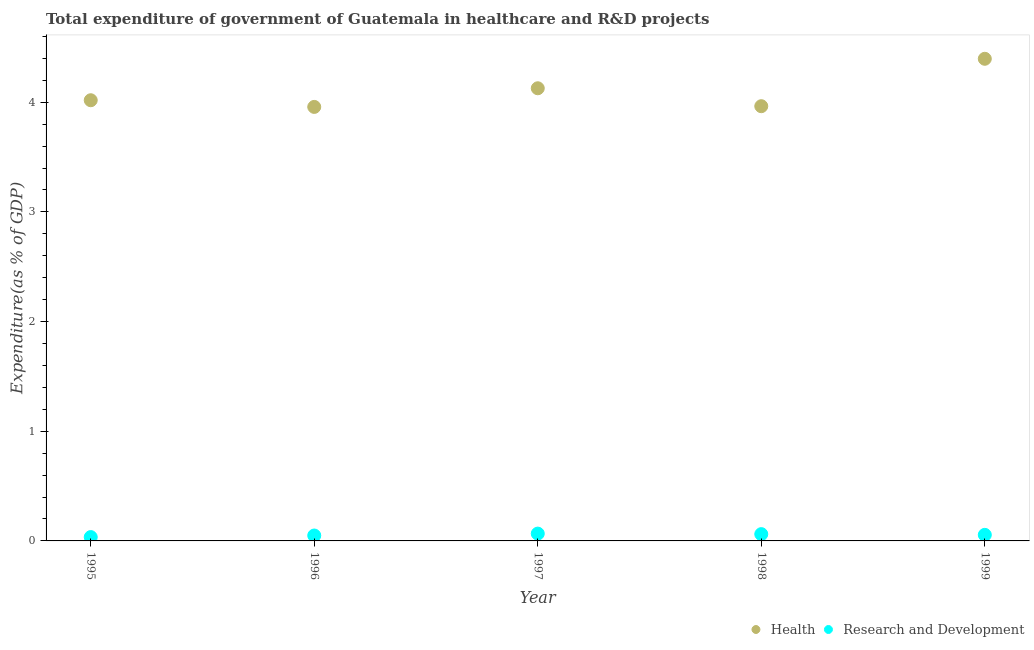Is the number of dotlines equal to the number of legend labels?
Your answer should be compact. Yes. What is the expenditure in r&d in 1998?
Provide a succinct answer. 0.06. Across all years, what is the maximum expenditure in r&d?
Make the answer very short. 0.07. Across all years, what is the minimum expenditure in r&d?
Offer a terse response. 0.04. What is the total expenditure in r&d in the graph?
Make the answer very short. 0.27. What is the difference between the expenditure in r&d in 1995 and that in 1996?
Your answer should be compact. -0.01. What is the difference between the expenditure in r&d in 1997 and the expenditure in healthcare in 1999?
Make the answer very short. -4.33. What is the average expenditure in r&d per year?
Make the answer very short. 0.05. In the year 1995, what is the difference between the expenditure in healthcare and expenditure in r&d?
Provide a short and direct response. 3.98. In how many years, is the expenditure in r&d greater than 2.8 %?
Keep it short and to the point. 0. What is the ratio of the expenditure in r&d in 1996 to that in 1997?
Offer a very short reply. 0.74. Is the expenditure in healthcare in 1998 less than that in 1999?
Your answer should be very brief. Yes. What is the difference between the highest and the second highest expenditure in healthcare?
Your answer should be very brief. 0.27. What is the difference between the highest and the lowest expenditure in healthcare?
Your answer should be very brief. 0.44. Is the sum of the expenditure in healthcare in 1996 and 1999 greater than the maximum expenditure in r&d across all years?
Make the answer very short. Yes. Does the expenditure in r&d monotonically increase over the years?
Offer a very short reply. No. How many years are there in the graph?
Your answer should be very brief. 5. What is the difference between two consecutive major ticks on the Y-axis?
Your answer should be very brief. 1. Are the values on the major ticks of Y-axis written in scientific E-notation?
Offer a terse response. No. Does the graph contain grids?
Keep it short and to the point. No. Where does the legend appear in the graph?
Offer a terse response. Bottom right. How are the legend labels stacked?
Offer a terse response. Horizontal. What is the title of the graph?
Provide a succinct answer. Total expenditure of government of Guatemala in healthcare and R&D projects. Does "Goods and services" appear as one of the legend labels in the graph?
Your response must be concise. No. What is the label or title of the X-axis?
Offer a terse response. Year. What is the label or title of the Y-axis?
Your answer should be compact. Expenditure(as % of GDP). What is the Expenditure(as % of GDP) in Health in 1995?
Ensure brevity in your answer.  4.02. What is the Expenditure(as % of GDP) in Research and Development in 1995?
Keep it short and to the point. 0.04. What is the Expenditure(as % of GDP) in Health in 1996?
Provide a succinct answer. 3.96. What is the Expenditure(as % of GDP) in Research and Development in 1996?
Give a very brief answer. 0.05. What is the Expenditure(as % of GDP) of Health in 1997?
Provide a succinct answer. 4.13. What is the Expenditure(as % of GDP) in Research and Development in 1997?
Provide a succinct answer. 0.07. What is the Expenditure(as % of GDP) in Health in 1998?
Keep it short and to the point. 3.96. What is the Expenditure(as % of GDP) in Research and Development in 1998?
Offer a very short reply. 0.06. What is the Expenditure(as % of GDP) of Health in 1999?
Provide a short and direct response. 4.4. What is the Expenditure(as % of GDP) in Research and Development in 1999?
Make the answer very short. 0.06. Across all years, what is the maximum Expenditure(as % of GDP) of Health?
Your answer should be compact. 4.4. Across all years, what is the maximum Expenditure(as % of GDP) in Research and Development?
Your response must be concise. 0.07. Across all years, what is the minimum Expenditure(as % of GDP) in Health?
Offer a terse response. 3.96. Across all years, what is the minimum Expenditure(as % of GDP) in Research and Development?
Give a very brief answer. 0.04. What is the total Expenditure(as % of GDP) of Health in the graph?
Give a very brief answer. 20.46. What is the total Expenditure(as % of GDP) in Research and Development in the graph?
Your answer should be very brief. 0.27. What is the difference between the Expenditure(as % of GDP) in Health in 1995 and that in 1996?
Make the answer very short. 0.06. What is the difference between the Expenditure(as % of GDP) in Research and Development in 1995 and that in 1996?
Ensure brevity in your answer.  -0.01. What is the difference between the Expenditure(as % of GDP) in Health in 1995 and that in 1997?
Give a very brief answer. -0.11. What is the difference between the Expenditure(as % of GDP) of Research and Development in 1995 and that in 1997?
Ensure brevity in your answer.  -0.03. What is the difference between the Expenditure(as % of GDP) of Health in 1995 and that in 1998?
Your response must be concise. 0.05. What is the difference between the Expenditure(as % of GDP) in Research and Development in 1995 and that in 1998?
Give a very brief answer. -0.03. What is the difference between the Expenditure(as % of GDP) in Health in 1995 and that in 1999?
Ensure brevity in your answer.  -0.38. What is the difference between the Expenditure(as % of GDP) in Research and Development in 1995 and that in 1999?
Provide a short and direct response. -0.02. What is the difference between the Expenditure(as % of GDP) of Health in 1996 and that in 1997?
Your response must be concise. -0.17. What is the difference between the Expenditure(as % of GDP) in Research and Development in 1996 and that in 1997?
Make the answer very short. -0.02. What is the difference between the Expenditure(as % of GDP) in Health in 1996 and that in 1998?
Offer a very short reply. -0.01. What is the difference between the Expenditure(as % of GDP) of Research and Development in 1996 and that in 1998?
Your response must be concise. -0.01. What is the difference between the Expenditure(as % of GDP) of Health in 1996 and that in 1999?
Ensure brevity in your answer.  -0.44. What is the difference between the Expenditure(as % of GDP) in Research and Development in 1996 and that in 1999?
Provide a short and direct response. -0.01. What is the difference between the Expenditure(as % of GDP) in Health in 1997 and that in 1998?
Your answer should be compact. 0.16. What is the difference between the Expenditure(as % of GDP) in Research and Development in 1997 and that in 1998?
Your response must be concise. 0. What is the difference between the Expenditure(as % of GDP) in Health in 1997 and that in 1999?
Make the answer very short. -0.27. What is the difference between the Expenditure(as % of GDP) in Research and Development in 1997 and that in 1999?
Keep it short and to the point. 0.01. What is the difference between the Expenditure(as % of GDP) of Health in 1998 and that in 1999?
Your answer should be very brief. -0.43. What is the difference between the Expenditure(as % of GDP) of Research and Development in 1998 and that in 1999?
Your response must be concise. 0.01. What is the difference between the Expenditure(as % of GDP) in Health in 1995 and the Expenditure(as % of GDP) in Research and Development in 1996?
Your response must be concise. 3.97. What is the difference between the Expenditure(as % of GDP) of Health in 1995 and the Expenditure(as % of GDP) of Research and Development in 1997?
Offer a terse response. 3.95. What is the difference between the Expenditure(as % of GDP) of Health in 1995 and the Expenditure(as % of GDP) of Research and Development in 1998?
Your answer should be very brief. 3.96. What is the difference between the Expenditure(as % of GDP) of Health in 1995 and the Expenditure(as % of GDP) of Research and Development in 1999?
Your answer should be compact. 3.96. What is the difference between the Expenditure(as % of GDP) of Health in 1996 and the Expenditure(as % of GDP) of Research and Development in 1997?
Provide a succinct answer. 3.89. What is the difference between the Expenditure(as % of GDP) of Health in 1996 and the Expenditure(as % of GDP) of Research and Development in 1998?
Your answer should be very brief. 3.9. What is the difference between the Expenditure(as % of GDP) in Health in 1996 and the Expenditure(as % of GDP) in Research and Development in 1999?
Provide a succinct answer. 3.9. What is the difference between the Expenditure(as % of GDP) of Health in 1997 and the Expenditure(as % of GDP) of Research and Development in 1998?
Offer a very short reply. 4.07. What is the difference between the Expenditure(as % of GDP) in Health in 1997 and the Expenditure(as % of GDP) in Research and Development in 1999?
Provide a short and direct response. 4.07. What is the difference between the Expenditure(as % of GDP) in Health in 1998 and the Expenditure(as % of GDP) in Research and Development in 1999?
Provide a short and direct response. 3.91. What is the average Expenditure(as % of GDP) of Health per year?
Offer a terse response. 4.09. What is the average Expenditure(as % of GDP) in Research and Development per year?
Offer a very short reply. 0.05. In the year 1995, what is the difference between the Expenditure(as % of GDP) of Health and Expenditure(as % of GDP) of Research and Development?
Provide a short and direct response. 3.98. In the year 1996, what is the difference between the Expenditure(as % of GDP) of Health and Expenditure(as % of GDP) of Research and Development?
Ensure brevity in your answer.  3.91. In the year 1997, what is the difference between the Expenditure(as % of GDP) of Health and Expenditure(as % of GDP) of Research and Development?
Make the answer very short. 4.06. In the year 1998, what is the difference between the Expenditure(as % of GDP) in Health and Expenditure(as % of GDP) in Research and Development?
Provide a short and direct response. 3.9. In the year 1999, what is the difference between the Expenditure(as % of GDP) in Health and Expenditure(as % of GDP) in Research and Development?
Provide a short and direct response. 4.34. What is the ratio of the Expenditure(as % of GDP) in Health in 1995 to that in 1996?
Your answer should be compact. 1.02. What is the ratio of the Expenditure(as % of GDP) of Research and Development in 1995 to that in 1996?
Offer a terse response. 0.71. What is the ratio of the Expenditure(as % of GDP) of Health in 1995 to that in 1997?
Offer a very short reply. 0.97. What is the ratio of the Expenditure(as % of GDP) of Research and Development in 1995 to that in 1997?
Offer a very short reply. 0.52. What is the ratio of the Expenditure(as % of GDP) in Health in 1995 to that in 1998?
Ensure brevity in your answer.  1.01. What is the ratio of the Expenditure(as % of GDP) in Research and Development in 1995 to that in 1998?
Provide a short and direct response. 0.57. What is the ratio of the Expenditure(as % of GDP) in Health in 1995 to that in 1999?
Provide a succinct answer. 0.91. What is the ratio of the Expenditure(as % of GDP) in Research and Development in 1995 to that in 1999?
Your answer should be compact. 0.63. What is the ratio of the Expenditure(as % of GDP) in Health in 1996 to that in 1997?
Offer a terse response. 0.96. What is the ratio of the Expenditure(as % of GDP) in Research and Development in 1996 to that in 1997?
Your answer should be compact. 0.74. What is the ratio of the Expenditure(as % of GDP) in Health in 1996 to that in 1998?
Offer a terse response. 1. What is the ratio of the Expenditure(as % of GDP) of Research and Development in 1996 to that in 1998?
Keep it short and to the point. 0.8. What is the ratio of the Expenditure(as % of GDP) of Health in 1996 to that in 1999?
Your response must be concise. 0.9. What is the ratio of the Expenditure(as % of GDP) of Research and Development in 1996 to that in 1999?
Your answer should be compact. 0.89. What is the ratio of the Expenditure(as % of GDP) in Health in 1997 to that in 1998?
Keep it short and to the point. 1.04. What is the ratio of the Expenditure(as % of GDP) of Research and Development in 1997 to that in 1998?
Your answer should be very brief. 1.08. What is the ratio of the Expenditure(as % of GDP) of Health in 1997 to that in 1999?
Make the answer very short. 0.94. What is the ratio of the Expenditure(as % of GDP) in Research and Development in 1997 to that in 1999?
Your answer should be very brief. 1.21. What is the ratio of the Expenditure(as % of GDP) in Health in 1998 to that in 1999?
Give a very brief answer. 0.9. What is the ratio of the Expenditure(as % of GDP) in Research and Development in 1998 to that in 1999?
Keep it short and to the point. 1.12. What is the difference between the highest and the second highest Expenditure(as % of GDP) of Health?
Provide a succinct answer. 0.27. What is the difference between the highest and the second highest Expenditure(as % of GDP) in Research and Development?
Offer a terse response. 0. What is the difference between the highest and the lowest Expenditure(as % of GDP) in Health?
Keep it short and to the point. 0.44. What is the difference between the highest and the lowest Expenditure(as % of GDP) in Research and Development?
Your answer should be very brief. 0.03. 